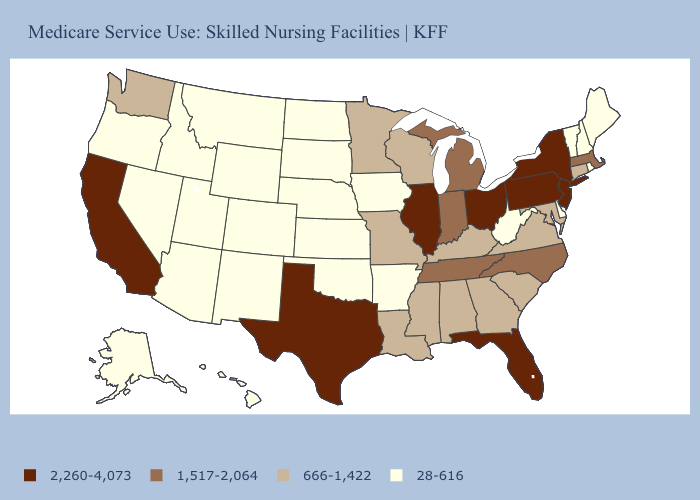What is the lowest value in the South?
Be succinct. 28-616. What is the lowest value in the South?
Concise answer only. 28-616. Name the states that have a value in the range 666-1,422?
Keep it brief. Alabama, Connecticut, Georgia, Kentucky, Louisiana, Maryland, Minnesota, Mississippi, Missouri, South Carolina, Virginia, Washington, Wisconsin. What is the value of Maryland?
Be succinct. 666-1,422. What is the highest value in the USA?
Concise answer only. 2,260-4,073. Name the states that have a value in the range 666-1,422?
Be succinct. Alabama, Connecticut, Georgia, Kentucky, Louisiana, Maryland, Minnesota, Mississippi, Missouri, South Carolina, Virginia, Washington, Wisconsin. Name the states that have a value in the range 2,260-4,073?
Write a very short answer. California, Florida, Illinois, New Jersey, New York, Ohio, Pennsylvania, Texas. Name the states that have a value in the range 666-1,422?
Keep it brief. Alabama, Connecticut, Georgia, Kentucky, Louisiana, Maryland, Minnesota, Mississippi, Missouri, South Carolina, Virginia, Washington, Wisconsin. Name the states that have a value in the range 1,517-2,064?
Write a very short answer. Indiana, Massachusetts, Michigan, North Carolina, Tennessee. Does Montana have the lowest value in the USA?
Be succinct. Yes. Does Vermont have the lowest value in the Northeast?
Write a very short answer. Yes. Name the states that have a value in the range 28-616?
Short answer required. Alaska, Arizona, Arkansas, Colorado, Delaware, Hawaii, Idaho, Iowa, Kansas, Maine, Montana, Nebraska, Nevada, New Hampshire, New Mexico, North Dakota, Oklahoma, Oregon, Rhode Island, South Dakota, Utah, Vermont, West Virginia, Wyoming. Among the states that border Louisiana , does Texas have the highest value?
Answer briefly. Yes. What is the lowest value in the MidWest?
Short answer required. 28-616. Does South Dakota have the lowest value in the MidWest?
Keep it brief. Yes. 